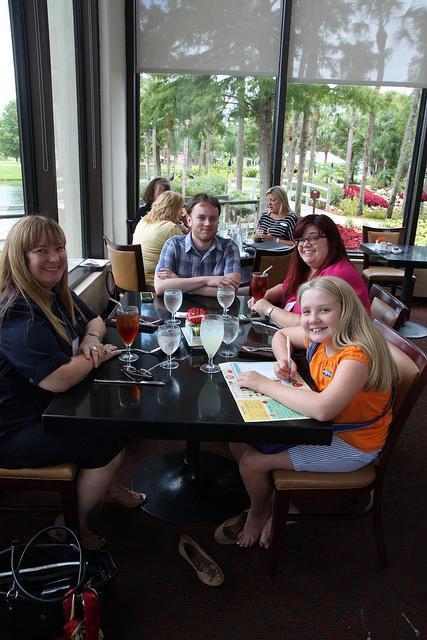How many people in the photo?
Give a very brief answer. 7. How many chairs are in the photo?
Give a very brief answer. 2. How many people are there?
Give a very brief answer. 5. 